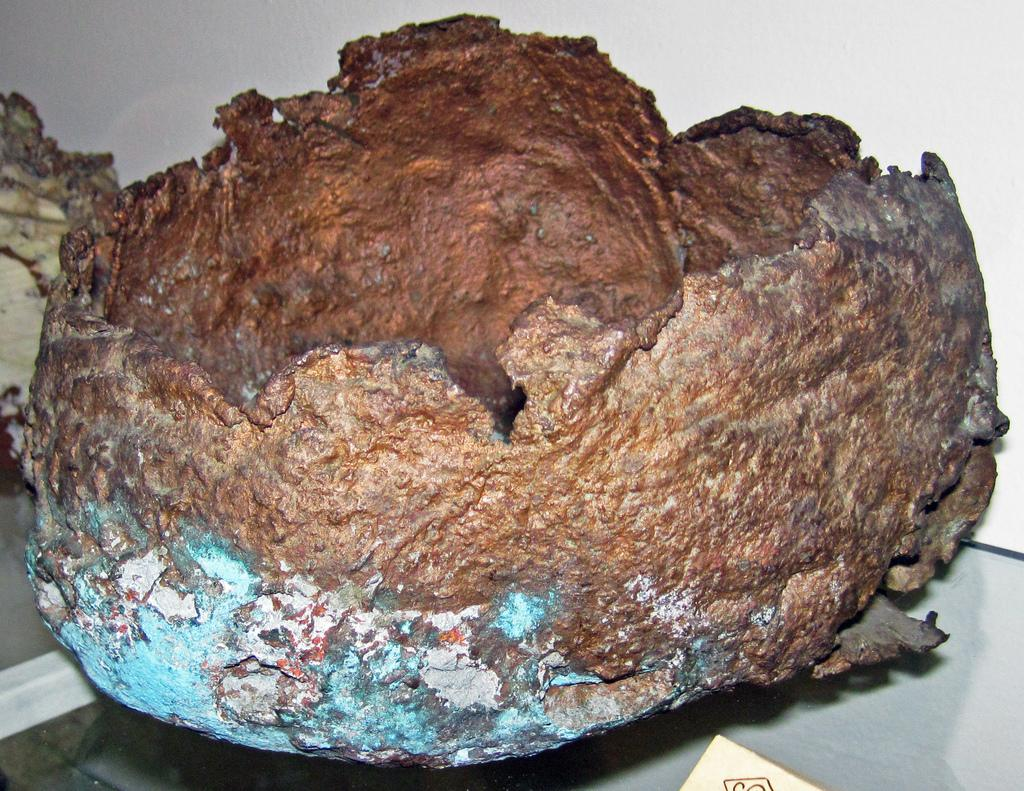What colors are present in the object in the image? The object in the image has brown, white, and blue colors. What is the object placed on in the image? The object is on a glass surface. What color is the background of the image? The background of the image is white. Can you tell me how many branches are sticking out of the quicksand in the image? There is no quicksand or branches present in the image. What type of humor can be seen in the image? There is no humor depicted in the image; it is a straightforward representation of a colored object on a glass surface with a white background. 